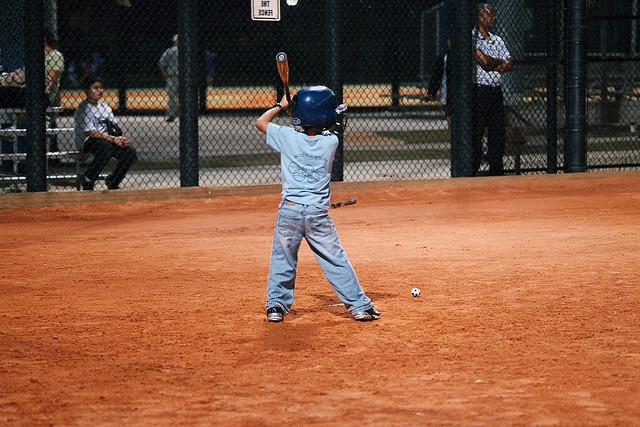Describe the objects in this image and their specific colors. I can see people in black, darkgray, and lightblue tones, people in black, gray, darkgray, and maroon tones, people in black, gray, darkgray, and maroon tones, bench in black, gray, lightgray, and darkgray tones, and people in black, gray, darkgray, and maroon tones in this image. 